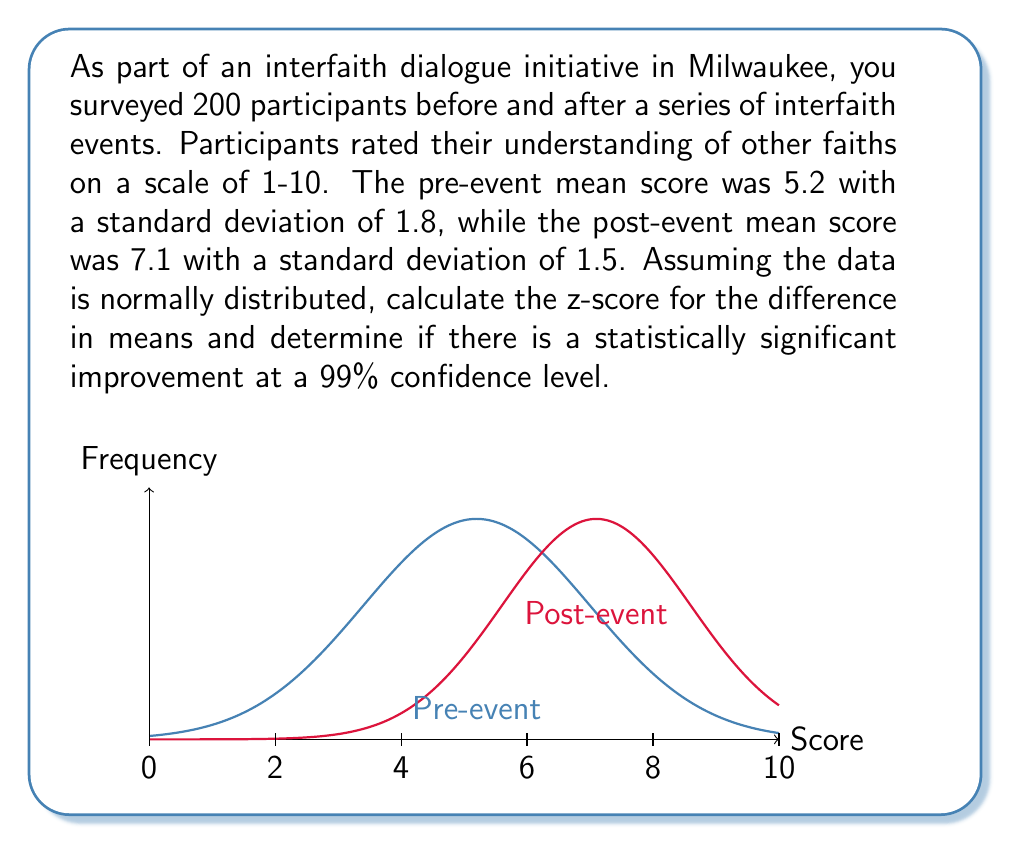Solve this math problem. Let's approach this step-by-step:

1) We're dealing with paired samples (before and after), so we need to use the formula for the standard error of the difference between two means:

   $$SE = \sqrt{\frac{s_1^2}{n_1} + \frac{s_2^2}{n_2}}$$

   where $s_1$ and $s_2$ are the standard deviations, and $n_1$ and $n_2$ are the sample sizes.

2) Calculate the standard error:

   $$SE = \sqrt{\frac{1.8^2}{200} + \frac{1.5^2}{200}} = \sqrt{\frac{3.24}{200} + \frac{2.25}{200}} = \sqrt{0.02745} \approx 0.1657$$

3) The difference in means is:

   $$\text{Difference} = 7.1 - 5.2 = 1.9$$

4) Calculate the z-score:

   $$z = \frac{\text{Difference}}{SE} = \frac{1.9}{0.1657} \approx 11.47$$

5) For a 99% confidence level, the critical z-value is 2.576 (two-tailed test).

6) Since our calculated z-score (11.47) is greater than the critical value (2.576), we can conclude that there is a statistically significant improvement.
Answer: $z \approx 11.47$; statistically significant improvement 